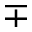<formula> <loc_0><loc_0><loc_500><loc_500>\mp</formula> 